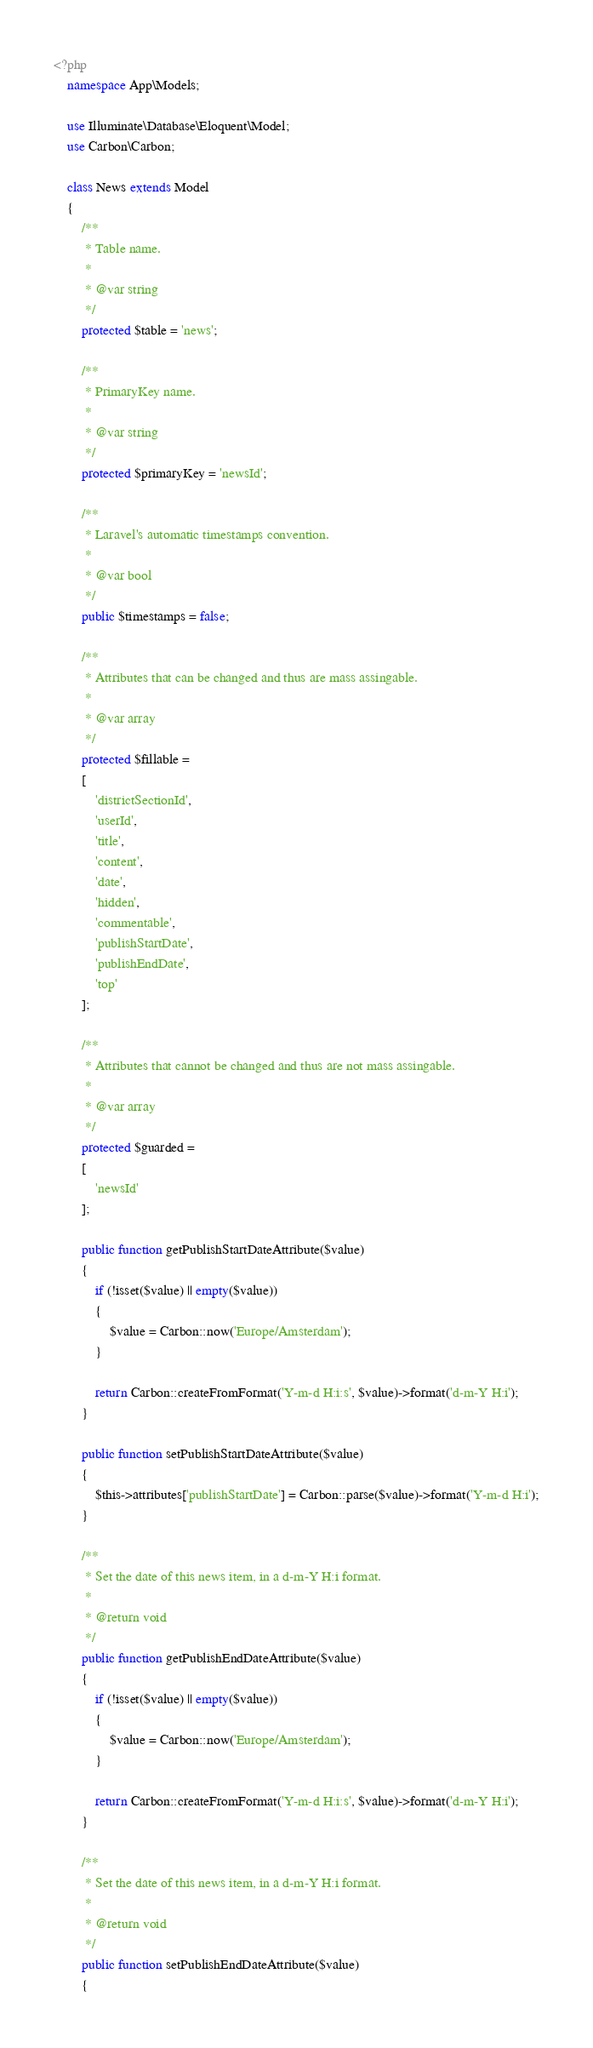<code> <loc_0><loc_0><loc_500><loc_500><_PHP_><?php 
	namespace App\Models;

	use Illuminate\Database\Eloquent\Model;
	use Carbon\Carbon;

	class News extends Model 
	{
		/**
		 * Table name.
		 * 
		 * @var string
		 */
		protected $table = 'news';

		/**
		 * PrimaryKey name.
		 * 
		 * @var string
		 */
		protected $primaryKey = 'newsId';

		/**
		 * Laravel's automatic timestamps convention.
		 * 
		 * @var bool
		 */
		public $timestamps = false;

		/**
		 * Attributes that can be changed and thus are mass assingable.
		 * 
		 * @var array
		 */
		protected $fillable = 
		[
			'districtSectionId', 
			'userId', 
			'title', 
			'content', 
			'date', 
			'hidden', 
			'commentable',
			'publishStartDate',
			'publishEndDate',
			'top'
		];

		/**
		 * Attributes that cannot be changed and thus are not mass assingable.
		 * 
		 * @var array
		 */
		protected $guarded = 
		[
			'newsId'
		];

		public function getPublishStartDateAttribute($value)
		{
			if (!isset($value) || empty($value))
			{
				$value = Carbon::now('Europe/Amsterdam');
			}

			return Carbon::createFromFormat('Y-m-d H:i:s', $value)->format('d-m-Y H:i');
		}

		public function setPublishStartDateAttribute($value)
		{
			$this->attributes['publishStartDate'] = Carbon::parse($value)->format('Y-m-d H:i');
		}

		/**
		 * Set the date of this news item, in a d-m-Y H:i format.
		 *
		 * @return void
		 */
		public function getPublishEndDateAttribute($value)
		{
			if (!isset($value) || empty($value))
			{
				$value = Carbon::now('Europe/Amsterdam');
			}

			return Carbon::createFromFormat('Y-m-d H:i:s', $value)->format('d-m-Y H:i');
		}

		/**
		 * Set the date of this news item, in a d-m-Y H:i format.
		 *
		 * @return void
		 */
		public function setPublishEndDateAttribute($value)
		{</code> 